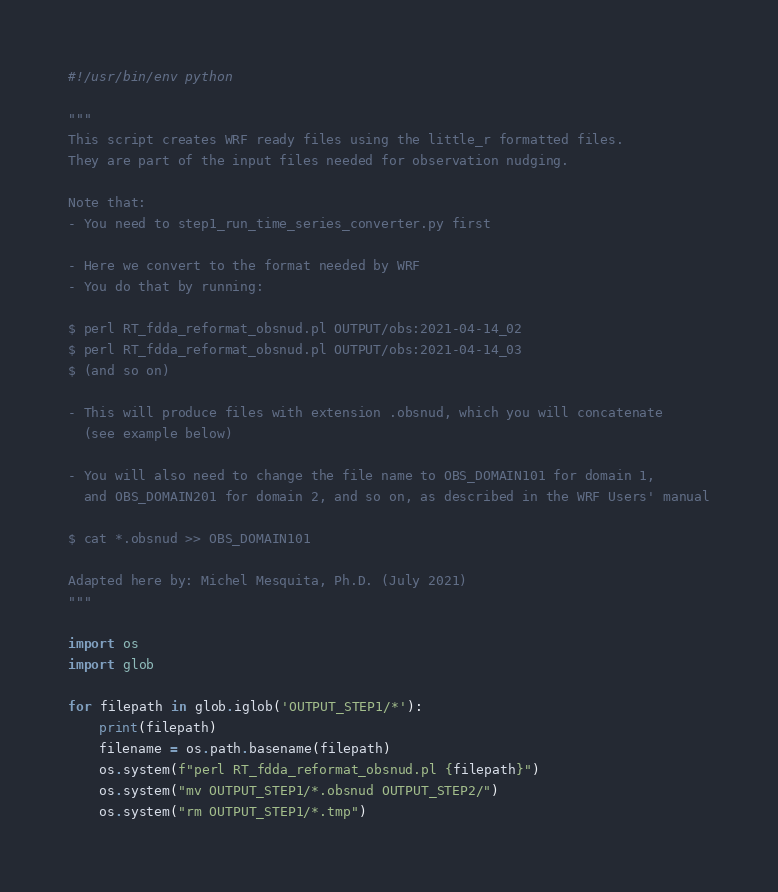Convert code to text. <code><loc_0><loc_0><loc_500><loc_500><_Python_>#!/usr/bin/env python

"""
This script creates WRF ready files using the little_r formatted files. 
They are part of the input files needed for observation nudging.

Note that: 
- You need to step1_run_time_series_converter.py first

- Here we convert to the format needed by WRF
- You do that by running: 

$ perl RT_fdda_reformat_obsnud.pl OUTPUT/obs:2021-04-14_02
$ perl RT_fdda_reformat_obsnud.pl OUTPUT/obs:2021-04-14_03
$ (and so on)

- This will produce files with extension .obsnud, which you will concatenate
  (see example below)

- You will also need to change the file name to OBS_DOMAIN101 for domain 1, 
  and OBS_DOMAIN201 for domain 2, and so on, as described in the WRF Users' manual

$ cat *.obsnud >> OBS_DOMAIN101

Adapted here by: Michel Mesquita, Ph.D. (July 2021)
"""

import os
import glob

for filepath in glob.iglob('OUTPUT_STEP1/*'):
    print(filepath)
    filename = os.path.basename(filepath)
    os.system(f"perl RT_fdda_reformat_obsnud.pl {filepath}")
    os.system("mv OUTPUT_STEP1/*.obsnud OUTPUT_STEP2/")
    os.system("rm OUTPUT_STEP1/*.tmp")

</code> 